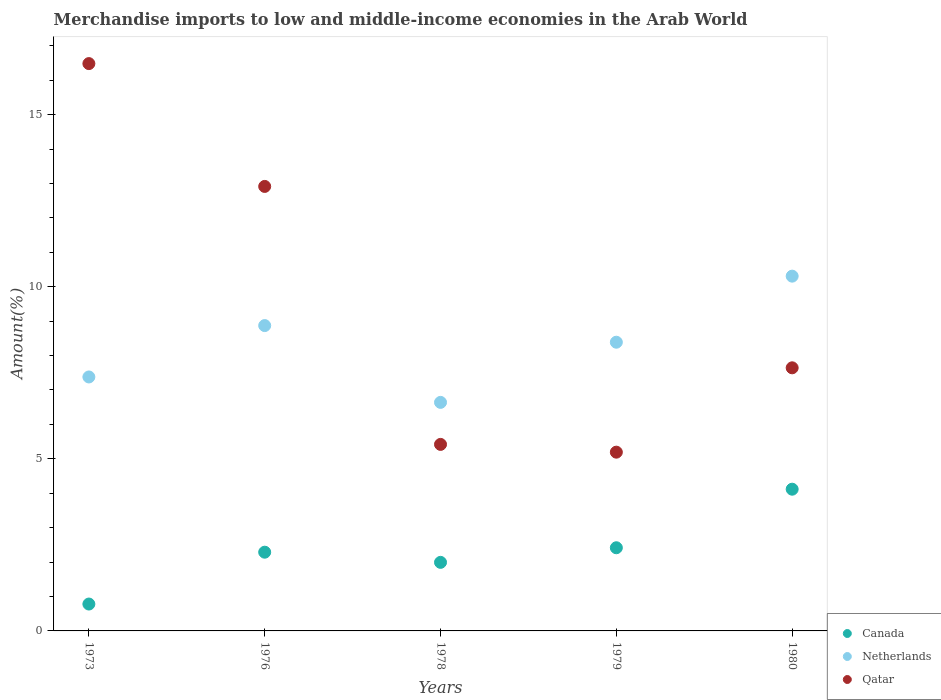What is the percentage of amount earned from merchandise imports in Qatar in 1979?
Offer a terse response. 5.19. Across all years, what is the maximum percentage of amount earned from merchandise imports in Canada?
Make the answer very short. 4.12. Across all years, what is the minimum percentage of amount earned from merchandise imports in Netherlands?
Your response must be concise. 6.64. In which year was the percentage of amount earned from merchandise imports in Canada minimum?
Keep it short and to the point. 1973. What is the total percentage of amount earned from merchandise imports in Qatar in the graph?
Your response must be concise. 47.65. What is the difference between the percentage of amount earned from merchandise imports in Canada in 1978 and that in 1979?
Offer a very short reply. -0.42. What is the difference between the percentage of amount earned from merchandise imports in Canada in 1973 and the percentage of amount earned from merchandise imports in Netherlands in 1978?
Offer a very short reply. -5.86. What is the average percentage of amount earned from merchandise imports in Netherlands per year?
Your answer should be compact. 8.32. In the year 1980, what is the difference between the percentage of amount earned from merchandise imports in Qatar and percentage of amount earned from merchandise imports in Canada?
Offer a very short reply. 3.53. In how many years, is the percentage of amount earned from merchandise imports in Canada greater than 1 %?
Offer a very short reply. 4. What is the ratio of the percentage of amount earned from merchandise imports in Canada in 1976 to that in 1980?
Offer a very short reply. 0.56. Is the percentage of amount earned from merchandise imports in Canada in 1973 less than that in 1979?
Your response must be concise. Yes. What is the difference between the highest and the second highest percentage of amount earned from merchandise imports in Canada?
Provide a short and direct response. 1.7. What is the difference between the highest and the lowest percentage of amount earned from merchandise imports in Netherlands?
Your response must be concise. 3.67. In how many years, is the percentage of amount earned from merchandise imports in Netherlands greater than the average percentage of amount earned from merchandise imports in Netherlands taken over all years?
Keep it short and to the point. 3. Is the sum of the percentage of amount earned from merchandise imports in Netherlands in 1973 and 1979 greater than the maximum percentage of amount earned from merchandise imports in Qatar across all years?
Provide a succinct answer. No. Does the percentage of amount earned from merchandise imports in Canada monotonically increase over the years?
Ensure brevity in your answer.  No. Is the percentage of amount earned from merchandise imports in Qatar strictly greater than the percentage of amount earned from merchandise imports in Canada over the years?
Give a very brief answer. Yes. How many years are there in the graph?
Keep it short and to the point. 5. Does the graph contain any zero values?
Provide a short and direct response. No. How many legend labels are there?
Make the answer very short. 3. What is the title of the graph?
Offer a very short reply. Merchandise imports to low and middle-income economies in the Arab World. What is the label or title of the Y-axis?
Offer a very short reply. Amount(%). What is the Amount(%) of Canada in 1973?
Ensure brevity in your answer.  0.78. What is the Amount(%) of Netherlands in 1973?
Provide a short and direct response. 7.38. What is the Amount(%) of Qatar in 1973?
Provide a succinct answer. 16.48. What is the Amount(%) of Canada in 1976?
Your answer should be compact. 2.29. What is the Amount(%) in Netherlands in 1976?
Provide a succinct answer. 8.87. What is the Amount(%) in Qatar in 1976?
Your answer should be very brief. 12.91. What is the Amount(%) of Canada in 1978?
Your response must be concise. 1.99. What is the Amount(%) of Netherlands in 1978?
Ensure brevity in your answer.  6.64. What is the Amount(%) of Qatar in 1978?
Your response must be concise. 5.42. What is the Amount(%) of Canada in 1979?
Your answer should be very brief. 2.42. What is the Amount(%) in Netherlands in 1979?
Keep it short and to the point. 8.39. What is the Amount(%) of Qatar in 1979?
Ensure brevity in your answer.  5.19. What is the Amount(%) in Canada in 1980?
Your answer should be very brief. 4.12. What is the Amount(%) of Netherlands in 1980?
Give a very brief answer. 10.31. What is the Amount(%) in Qatar in 1980?
Give a very brief answer. 7.64. Across all years, what is the maximum Amount(%) in Canada?
Provide a short and direct response. 4.12. Across all years, what is the maximum Amount(%) of Netherlands?
Provide a succinct answer. 10.31. Across all years, what is the maximum Amount(%) of Qatar?
Offer a terse response. 16.48. Across all years, what is the minimum Amount(%) of Canada?
Your response must be concise. 0.78. Across all years, what is the minimum Amount(%) of Netherlands?
Make the answer very short. 6.64. Across all years, what is the minimum Amount(%) of Qatar?
Ensure brevity in your answer.  5.19. What is the total Amount(%) in Canada in the graph?
Offer a very short reply. 11.59. What is the total Amount(%) in Netherlands in the graph?
Your answer should be very brief. 41.59. What is the total Amount(%) of Qatar in the graph?
Provide a succinct answer. 47.65. What is the difference between the Amount(%) of Canada in 1973 and that in 1976?
Your answer should be compact. -1.51. What is the difference between the Amount(%) of Netherlands in 1973 and that in 1976?
Your answer should be very brief. -1.49. What is the difference between the Amount(%) in Qatar in 1973 and that in 1976?
Make the answer very short. 3.57. What is the difference between the Amount(%) of Canada in 1973 and that in 1978?
Provide a succinct answer. -1.21. What is the difference between the Amount(%) of Netherlands in 1973 and that in 1978?
Offer a very short reply. 0.74. What is the difference between the Amount(%) of Qatar in 1973 and that in 1978?
Offer a very short reply. 11.06. What is the difference between the Amount(%) of Canada in 1973 and that in 1979?
Your answer should be very brief. -1.64. What is the difference between the Amount(%) in Netherlands in 1973 and that in 1979?
Provide a succinct answer. -1.01. What is the difference between the Amount(%) of Qatar in 1973 and that in 1979?
Ensure brevity in your answer.  11.29. What is the difference between the Amount(%) of Canada in 1973 and that in 1980?
Keep it short and to the point. -3.34. What is the difference between the Amount(%) in Netherlands in 1973 and that in 1980?
Keep it short and to the point. -2.93. What is the difference between the Amount(%) of Qatar in 1973 and that in 1980?
Provide a succinct answer. 8.84. What is the difference between the Amount(%) of Canada in 1976 and that in 1978?
Offer a terse response. 0.3. What is the difference between the Amount(%) of Netherlands in 1976 and that in 1978?
Offer a very short reply. 2.23. What is the difference between the Amount(%) of Qatar in 1976 and that in 1978?
Offer a terse response. 7.5. What is the difference between the Amount(%) in Canada in 1976 and that in 1979?
Your answer should be very brief. -0.13. What is the difference between the Amount(%) in Netherlands in 1976 and that in 1979?
Offer a very short reply. 0.48. What is the difference between the Amount(%) in Qatar in 1976 and that in 1979?
Your answer should be compact. 7.72. What is the difference between the Amount(%) in Canada in 1976 and that in 1980?
Keep it short and to the point. -1.83. What is the difference between the Amount(%) in Netherlands in 1976 and that in 1980?
Provide a succinct answer. -1.44. What is the difference between the Amount(%) of Qatar in 1976 and that in 1980?
Provide a succinct answer. 5.27. What is the difference between the Amount(%) in Canada in 1978 and that in 1979?
Your answer should be very brief. -0.42. What is the difference between the Amount(%) in Netherlands in 1978 and that in 1979?
Provide a short and direct response. -1.75. What is the difference between the Amount(%) in Qatar in 1978 and that in 1979?
Provide a succinct answer. 0.23. What is the difference between the Amount(%) in Canada in 1978 and that in 1980?
Keep it short and to the point. -2.13. What is the difference between the Amount(%) of Netherlands in 1978 and that in 1980?
Offer a very short reply. -3.67. What is the difference between the Amount(%) of Qatar in 1978 and that in 1980?
Offer a very short reply. -2.23. What is the difference between the Amount(%) of Canada in 1979 and that in 1980?
Offer a terse response. -1.7. What is the difference between the Amount(%) of Netherlands in 1979 and that in 1980?
Offer a terse response. -1.92. What is the difference between the Amount(%) in Qatar in 1979 and that in 1980?
Your answer should be compact. -2.45. What is the difference between the Amount(%) in Canada in 1973 and the Amount(%) in Netherlands in 1976?
Provide a short and direct response. -8.09. What is the difference between the Amount(%) in Canada in 1973 and the Amount(%) in Qatar in 1976?
Your answer should be compact. -12.13. What is the difference between the Amount(%) in Netherlands in 1973 and the Amount(%) in Qatar in 1976?
Make the answer very short. -5.54. What is the difference between the Amount(%) in Canada in 1973 and the Amount(%) in Netherlands in 1978?
Provide a short and direct response. -5.86. What is the difference between the Amount(%) of Canada in 1973 and the Amount(%) of Qatar in 1978?
Your answer should be very brief. -4.64. What is the difference between the Amount(%) of Netherlands in 1973 and the Amount(%) of Qatar in 1978?
Provide a succinct answer. 1.96. What is the difference between the Amount(%) of Canada in 1973 and the Amount(%) of Netherlands in 1979?
Offer a terse response. -7.61. What is the difference between the Amount(%) in Canada in 1973 and the Amount(%) in Qatar in 1979?
Offer a terse response. -4.41. What is the difference between the Amount(%) in Netherlands in 1973 and the Amount(%) in Qatar in 1979?
Provide a short and direct response. 2.19. What is the difference between the Amount(%) in Canada in 1973 and the Amount(%) in Netherlands in 1980?
Provide a short and direct response. -9.53. What is the difference between the Amount(%) in Canada in 1973 and the Amount(%) in Qatar in 1980?
Offer a very short reply. -6.86. What is the difference between the Amount(%) in Netherlands in 1973 and the Amount(%) in Qatar in 1980?
Provide a short and direct response. -0.27. What is the difference between the Amount(%) of Canada in 1976 and the Amount(%) of Netherlands in 1978?
Your answer should be very brief. -4.35. What is the difference between the Amount(%) in Canada in 1976 and the Amount(%) in Qatar in 1978?
Provide a succinct answer. -3.13. What is the difference between the Amount(%) of Netherlands in 1976 and the Amount(%) of Qatar in 1978?
Offer a terse response. 3.45. What is the difference between the Amount(%) of Canada in 1976 and the Amount(%) of Netherlands in 1979?
Offer a very short reply. -6.1. What is the difference between the Amount(%) of Canada in 1976 and the Amount(%) of Qatar in 1979?
Your response must be concise. -2.91. What is the difference between the Amount(%) in Netherlands in 1976 and the Amount(%) in Qatar in 1979?
Provide a short and direct response. 3.68. What is the difference between the Amount(%) in Canada in 1976 and the Amount(%) in Netherlands in 1980?
Ensure brevity in your answer.  -8.02. What is the difference between the Amount(%) in Canada in 1976 and the Amount(%) in Qatar in 1980?
Make the answer very short. -5.36. What is the difference between the Amount(%) in Netherlands in 1976 and the Amount(%) in Qatar in 1980?
Keep it short and to the point. 1.23. What is the difference between the Amount(%) in Canada in 1978 and the Amount(%) in Netherlands in 1979?
Your answer should be compact. -6.4. What is the difference between the Amount(%) of Canada in 1978 and the Amount(%) of Qatar in 1979?
Offer a very short reply. -3.2. What is the difference between the Amount(%) in Netherlands in 1978 and the Amount(%) in Qatar in 1979?
Offer a terse response. 1.45. What is the difference between the Amount(%) of Canada in 1978 and the Amount(%) of Netherlands in 1980?
Give a very brief answer. -8.32. What is the difference between the Amount(%) in Canada in 1978 and the Amount(%) in Qatar in 1980?
Make the answer very short. -5.65. What is the difference between the Amount(%) of Netherlands in 1978 and the Amount(%) of Qatar in 1980?
Your answer should be compact. -1. What is the difference between the Amount(%) in Canada in 1979 and the Amount(%) in Netherlands in 1980?
Your answer should be compact. -7.89. What is the difference between the Amount(%) in Canada in 1979 and the Amount(%) in Qatar in 1980?
Your answer should be compact. -5.23. What is the difference between the Amount(%) in Netherlands in 1979 and the Amount(%) in Qatar in 1980?
Provide a succinct answer. 0.74. What is the average Amount(%) of Canada per year?
Give a very brief answer. 2.32. What is the average Amount(%) of Netherlands per year?
Your answer should be compact. 8.32. What is the average Amount(%) of Qatar per year?
Provide a short and direct response. 9.53. In the year 1973, what is the difference between the Amount(%) of Canada and Amount(%) of Netherlands?
Offer a very short reply. -6.6. In the year 1973, what is the difference between the Amount(%) in Canada and Amount(%) in Qatar?
Offer a very short reply. -15.7. In the year 1973, what is the difference between the Amount(%) of Netherlands and Amount(%) of Qatar?
Your answer should be very brief. -9.1. In the year 1976, what is the difference between the Amount(%) in Canada and Amount(%) in Netherlands?
Ensure brevity in your answer.  -6.58. In the year 1976, what is the difference between the Amount(%) of Canada and Amount(%) of Qatar?
Provide a succinct answer. -10.63. In the year 1976, what is the difference between the Amount(%) of Netherlands and Amount(%) of Qatar?
Provide a short and direct response. -4.04. In the year 1978, what is the difference between the Amount(%) in Canada and Amount(%) in Netherlands?
Offer a terse response. -4.65. In the year 1978, what is the difference between the Amount(%) in Canada and Amount(%) in Qatar?
Ensure brevity in your answer.  -3.43. In the year 1978, what is the difference between the Amount(%) in Netherlands and Amount(%) in Qatar?
Make the answer very short. 1.22. In the year 1979, what is the difference between the Amount(%) of Canada and Amount(%) of Netherlands?
Your answer should be very brief. -5.97. In the year 1979, what is the difference between the Amount(%) of Canada and Amount(%) of Qatar?
Your response must be concise. -2.78. In the year 1979, what is the difference between the Amount(%) in Netherlands and Amount(%) in Qatar?
Your answer should be very brief. 3.19. In the year 1980, what is the difference between the Amount(%) in Canada and Amount(%) in Netherlands?
Make the answer very short. -6.19. In the year 1980, what is the difference between the Amount(%) in Canada and Amount(%) in Qatar?
Provide a succinct answer. -3.53. In the year 1980, what is the difference between the Amount(%) of Netherlands and Amount(%) of Qatar?
Offer a terse response. 2.66. What is the ratio of the Amount(%) of Canada in 1973 to that in 1976?
Keep it short and to the point. 0.34. What is the ratio of the Amount(%) in Netherlands in 1973 to that in 1976?
Keep it short and to the point. 0.83. What is the ratio of the Amount(%) in Qatar in 1973 to that in 1976?
Give a very brief answer. 1.28. What is the ratio of the Amount(%) of Canada in 1973 to that in 1978?
Give a very brief answer. 0.39. What is the ratio of the Amount(%) of Netherlands in 1973 to that in 1978?
Offer a very short reply. 1.11. What is the ratio of the Amount(%) of Qatar in 1973 to that in 1978?
Offer a terse response. 3.04. What is the ratio of the Amount(%) of Canada in 1973 to that in 1979?
Provide a succinct answer. 0.32. What is the ratio of the Amount(%) in Netherlands in 1973 to that in 1979?
Offer a very short reply. 0.88. What is the ratio of the Amount(%) of Qatar in 1973 to that in 1979?
Your response must be concise. 3.17. What is the ratio of the Amount(%) in Canada in 1973 to that in 1980?
Offer a very short reply. 0.19. What is the ratio of the Amount(%) of Netherlands in 1973 to that in 1980?
Make the answer very short. 0.72. What is the ratio of the Amount(%) in Qatar in 1973 to that in 1980?
Provide a short and direct response. 2.16. What is the ratio of the Amount(%) of Canada in 1976 to that in 1978?
Give a very brief answer. 1.15. What is the ratio of the Amount(%) in Netherlands in 1976 to that in 1978?
Your answer should be compact. 1.34. What is the ratio of the Amount(%) in Qatar in 1976 to that in 1978?
Offer a terse response. 2.38. What is the ratio of the Amount(%) in Canada in 1976 to that in 1979?
Make the answer very short. 0.95. What is the ratio of the Amount(%) in Netherlands in 1976 to that in 1979?
Keep it short and to the point. 1.06. What is the ratio of the Amount(%) in Qatar in 1976 to that in 1979?
Give a very brief answer. 2.49. What is the ratio of the Amount(%) of Canada in 1976 to that in 1980?
Offer a terse response. 0.56. What is the ratio of the Amount(%) in Netherlands in 1976 to that in 1980?
Give a very brief answer. 0.86. What is the ratio of the Amount(%) of Qatar in 1976 to that in 1980?
Your answer should be compact. 1.69. What is the ratio of the Amount(%) in Canada in 1978 to that in 1979?
Give a very brief answer. 0.82. What is the ratio of the Amount(%) in Netherlands in 1978 to that in 1979?
Provide a succinct answer. 0.79. What is the ratio of the Amount(%) of Qatar in 1978 to that in 1979?
Your response must be concise. 1.04. What is the ratio of the Amount(%) in Canada in 1978 to that in 1980?
Your answer should be very brief. 0.48. What is the ratio of the Amount(%) in Netherlands in 1978 to that in 1980?
Your answer should be very brief. 0.64. What is the ratio of the Amount(%) in Qatar in 1978 to that in 1980?
Your response must be concise. 0.71. What is the ratio of the Amount(%) in Canada in 1979 to that in 1980?
Keep it short and to the point. 0.59. What is the ratio of the Amount(%) in Netherlands in 1979 to that in 1980?
Provide a short and direct response. 0.81. What is the ratio of the Amount(%) in Qatar in 1979 to that in 1980?
Make the answer very short. 0.68. What is the difference between the highest and the second highest Amount(%) in Canada?
Ensure brevity in your answer.  1.7. What is the difference between the highest and the second highest Amount(%) in Netherlands?
Make the answer very short. 1.44. What is the difference between the highest and the second highest Amount(%) of Qatar?
Make the answer very short. 3.57. What is the difference between the highest and the lowest Amount(%) of Canada?
Your answer should be very brief. 3.34. What is the difference between the highest and the lowest Amount(%) of Netherlands?
Keep it short and to the point. 3.67. What is the difference between the highest and the lowest Amount(%) of Qatar?
Give a very brief answer. 11.29. 